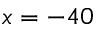Convert formula to latex. <formula><loc_0><loc_0><loc_500><loc_500>x = - 4 0</formula> 